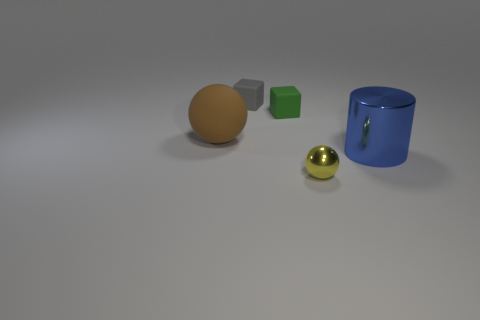The object that is the same material as the cylinder is what shape?
Your answer should be compact. Sphere. Do the metallic cylinder and the brown matte thing have the same size?
Your response must be concise. Yes. How big is the block to the right of the small gray matte cube that is behind the big matte object?
Give a very brief answer. Small. What number of cubes are blue shiny objects or yellow things?
Offer a terse response. 0. Is the size of the rubber sphere the same as the sphere to the right of the brown object?
Keep it short and to the point. No. Are there more large brown rubber objects that are on the left side of the tiny yellow metal sphere than large purple rubber spheres?
Your response must be concise. Yes. There is a sphere that is made of the same material as the small gray object; what is its size?
Provide a short and direct response. Large. How many objects are big brown matte balls or objects that are left of the metal sphere?
Offer a terse response. 3. Is the number of blue shiny things greater than the number of big green matte things?
Offer a terse response. Yes. Is there a big thing made of the same material as the yellow sphere?
Ensure brevity in your answer.  Yes. 